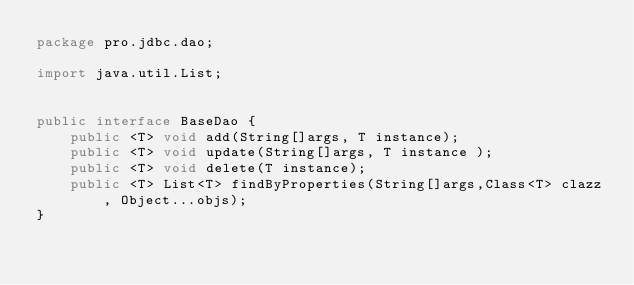<code> <loc_0><loc_0><loc_500><loc_500><_Java_>package pro.jdbc.dao;

import java.util.List;


public interface BaseDao {
	public <T> void add(String[]args, T instance);
	public <T> void update(String[]args, T instance );
	public <T> void delete(T instance);
	public <T> List<T> findByProperties(String[]args,Class<T> clazz, Object...objs);
}
</code> 